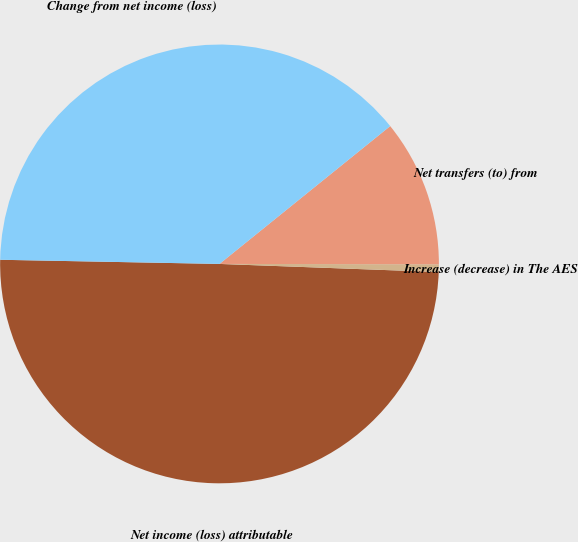Convert chart to OTSL. <chart><loc_0><loc_0><loc_500><loc_500><pie_chart><fcel>Net income (loss) attributable<fcel>Increase (decrease) in The AES<fcel>Net transfers (to) from<fcel>Change from net income (loss)<nl><fcel>49.72%<fcel>0.56%<fcel>10.84%<fcel>38.89%<nl></chart> 